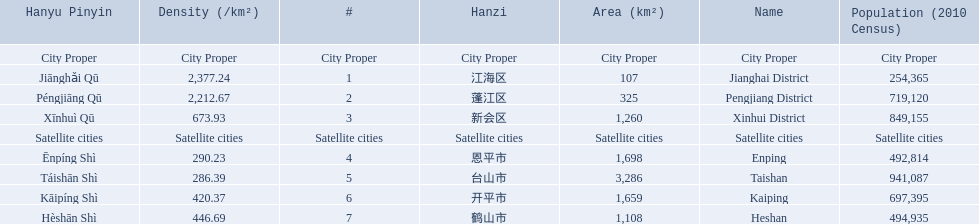What are all of the city proper district names? Jianghai District, Pengjiang District, Xinhui District. Of those districts, what are is the value for their area (km2)? 107, 325, 1,260. Of those area values, which district does the smallest value belong to? Jianghai District. 